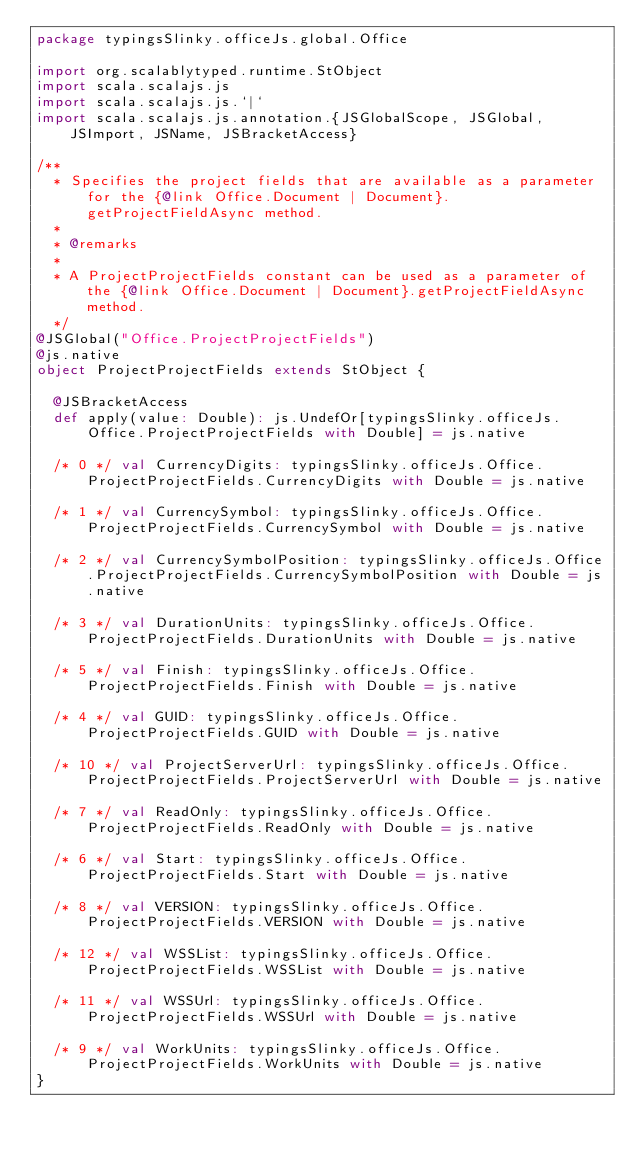<code> <loc_0><loc_0><loc_500><loc_500><_Scala_>package typingsSlinky.officeJs.global.Office

import org.scalablytyped.runtime.StObject
import scala.scalajs.js
import scala.scalajs.js.`|`
import scala.scalajs.js.annotation.{JSGlobalScope, JSGlobal, JSImport, JSName, JSBracketAccess}

/**
  * Specifies the project fields that are available as a parameter for the {@link Office.Document | Document}.getProjectFieldAsync method.
  *
  * @remarks
  * 
  * A ProjectProjectFields constant can be used as a parameter of the {@link Office.Document | Document}.getProjectFieldAsync method.
  */
@JSGlobal("Office.ProjectProjectFields")
@js.native
object ProjectProjectFields extends StObject {
  
  @JSBracketAccess
  def apply(value: Double): js.UndefOr[typingsSlinky.officeJs.Office.ProjectProjectFields with Double] = js.native
  
  /* 0 */ val CurrencyDigits: typingsSlinky.officeJs.Office.ProjectProjectFields.CurrencyDigits with Double = js.native
  
  /* 1 */ val CurrencySymbol: typingsSlinky.officeJs.Office.ProjectProjectFields.CurrencySymbol with Double = js.native
  
  /* 2 */ val CurrencySymbolPosition: typingsSlinky.officeJs.Office.ProjectProjectFields.CurrencySymbolPosition with Double = js.native
  
  /* 3 */ val DurationUnits: typingsSlinky.officeJs.Office.ProjectProjectFields.DurationUnits with Double = js.native
  
  /* 5 */ val Finish: typingsSlinky.officeJs.Office.ProjectProjectFields.Finish with Double = js.native
  
  /* 4 */ val GUID: typingsSlinky.officeJs.Office.ProjectProjectFields.GUID with Double = js.native
  
  /* 10 */ val ProjectServerUrl: typingsSlinky.officeJs.Office.ProjectProjectFields.ProjectServerUrl with Double = js.native
  
  /* 7 */ val ReadOnly: typingsSlinky.officeJs.Office.ProjectProjectFields.ReadOnly with Double = js.native
  
  /* 6 */ val Start: typingsSlinky.officeJs.Office.ProjectProjectFields.Start with Double = js.native
  
  /* 8 */ val VERSION: typingsSlinky.officeJs.Office.ProjectProjectFields.VERSION with Double = js.native
  
  /* 12 */ val WSSList: typingsSlinky.officeJs.Office.ProjectProjectFields.WSSList with Double = js.native
  
  /* 11 */ val WSSUrl: typingsSlinky.officeJs.Office.ProjectProjectFields.WSSUrl with Double = js.native
  
  /* 9 */ val WorkUnits: typingsSlinky.officeJs.Office.ProjectProjectFields.WorkUnits with Double = js.native
}
</code> 